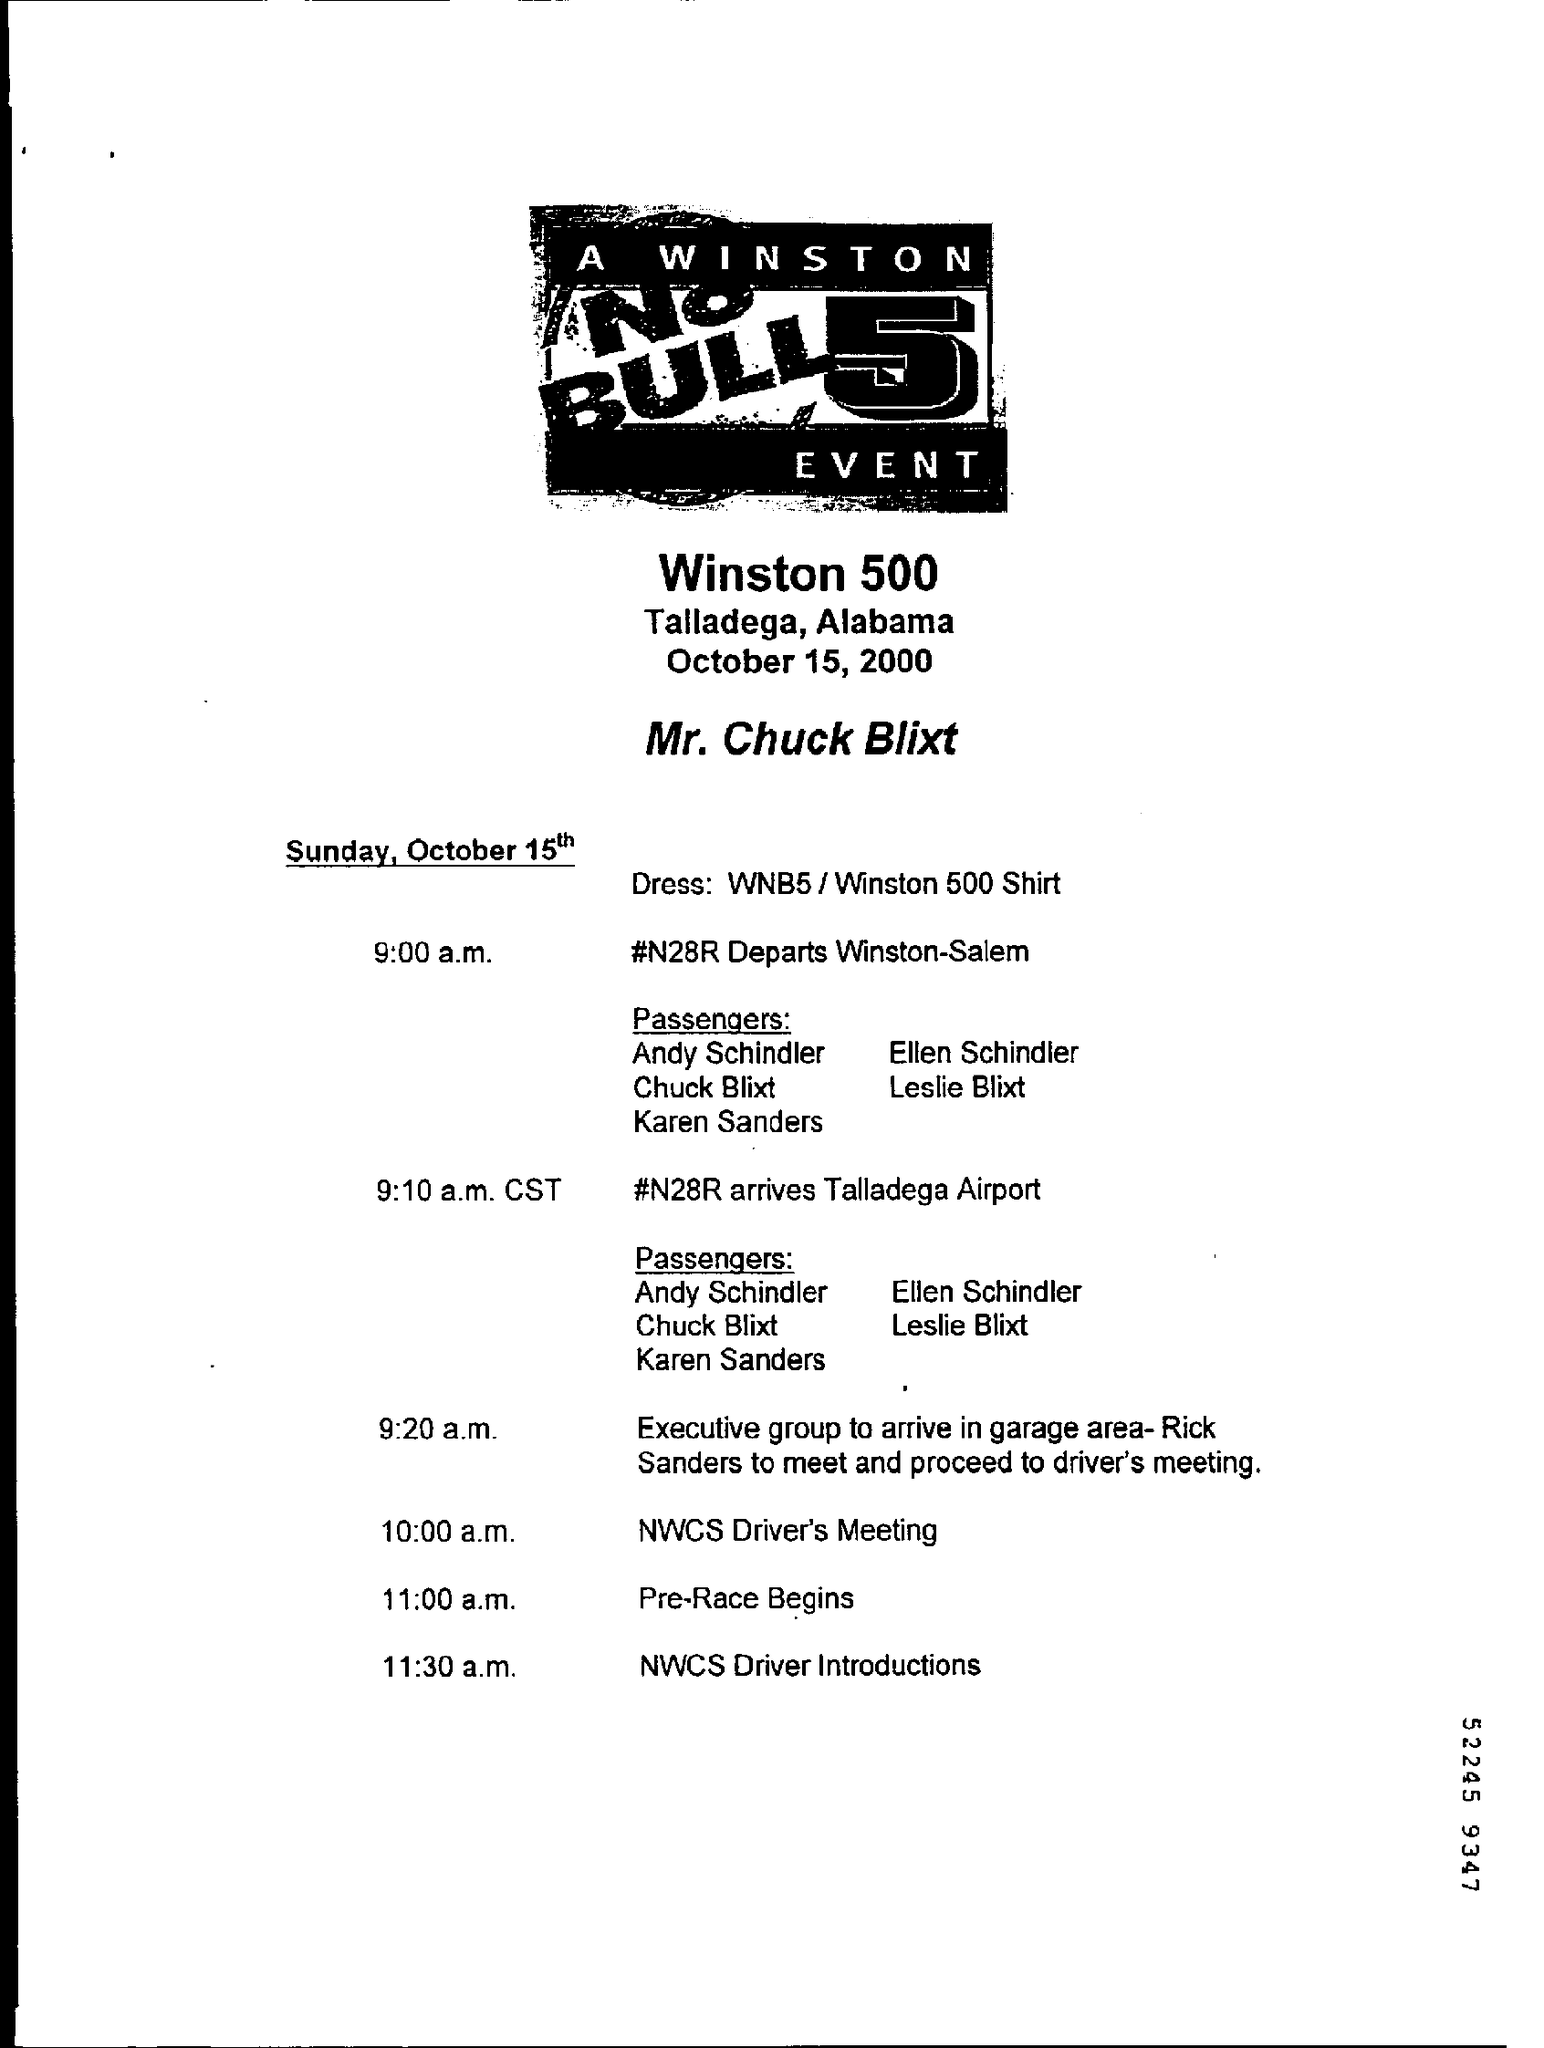What is the Place?
Offer a terse response. Talladega, Alabama. When does #N28R depart Winston-Salem?
Your answer should be very brief. 9:00 a.m. When does #N28R arrive at Talladega Airport?
Provide a succinct answer. 9:10 a.m. CST. When is NCWS Driver's Meeting?
Provide a short and direct response. 10:00 a.m. When is NCWS Driver Intorductions?
Your response must be concise. 11:30 a.m. 